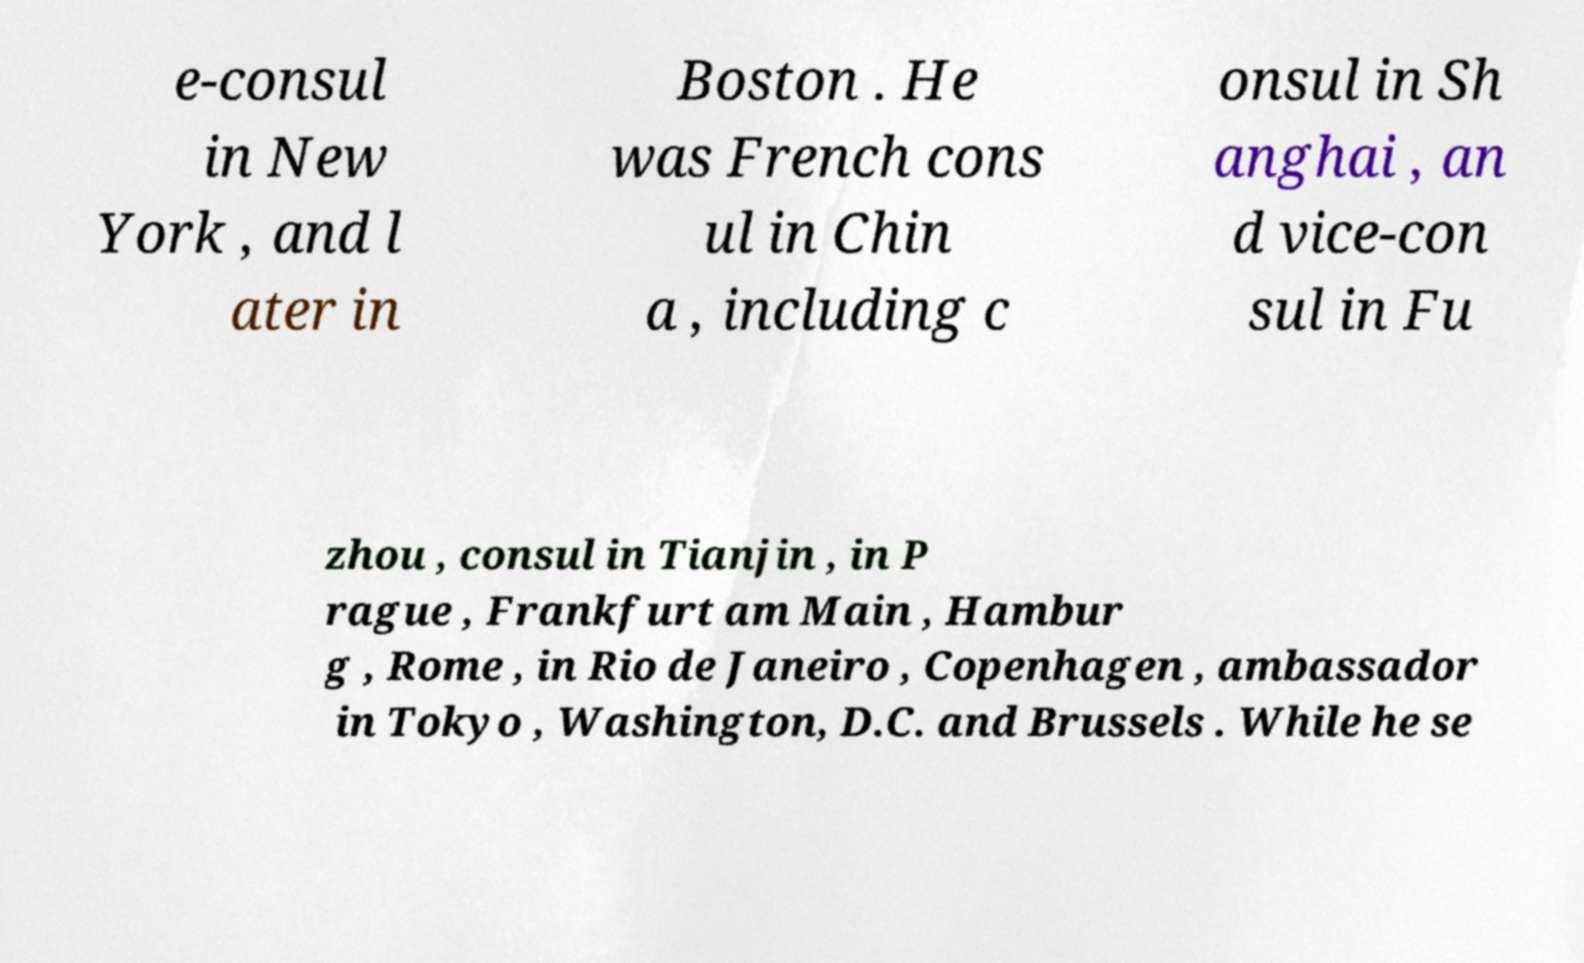There's text embedded in this image that I need extracted. Can you transcribe it verbatim? e-consul in New York , and l ater in Boston . He was French cons ul in Chin a , including c onsul in Sh anghai , an d vice-con sul in Fu zhou , consul in Tianjin , in P rague , Frankfurt am Main , Hambur g , Rome , in Rio de Janeiro , Copenhagen , ambassador in Tokyo , Washington, D.C. and Brussels . While he se 